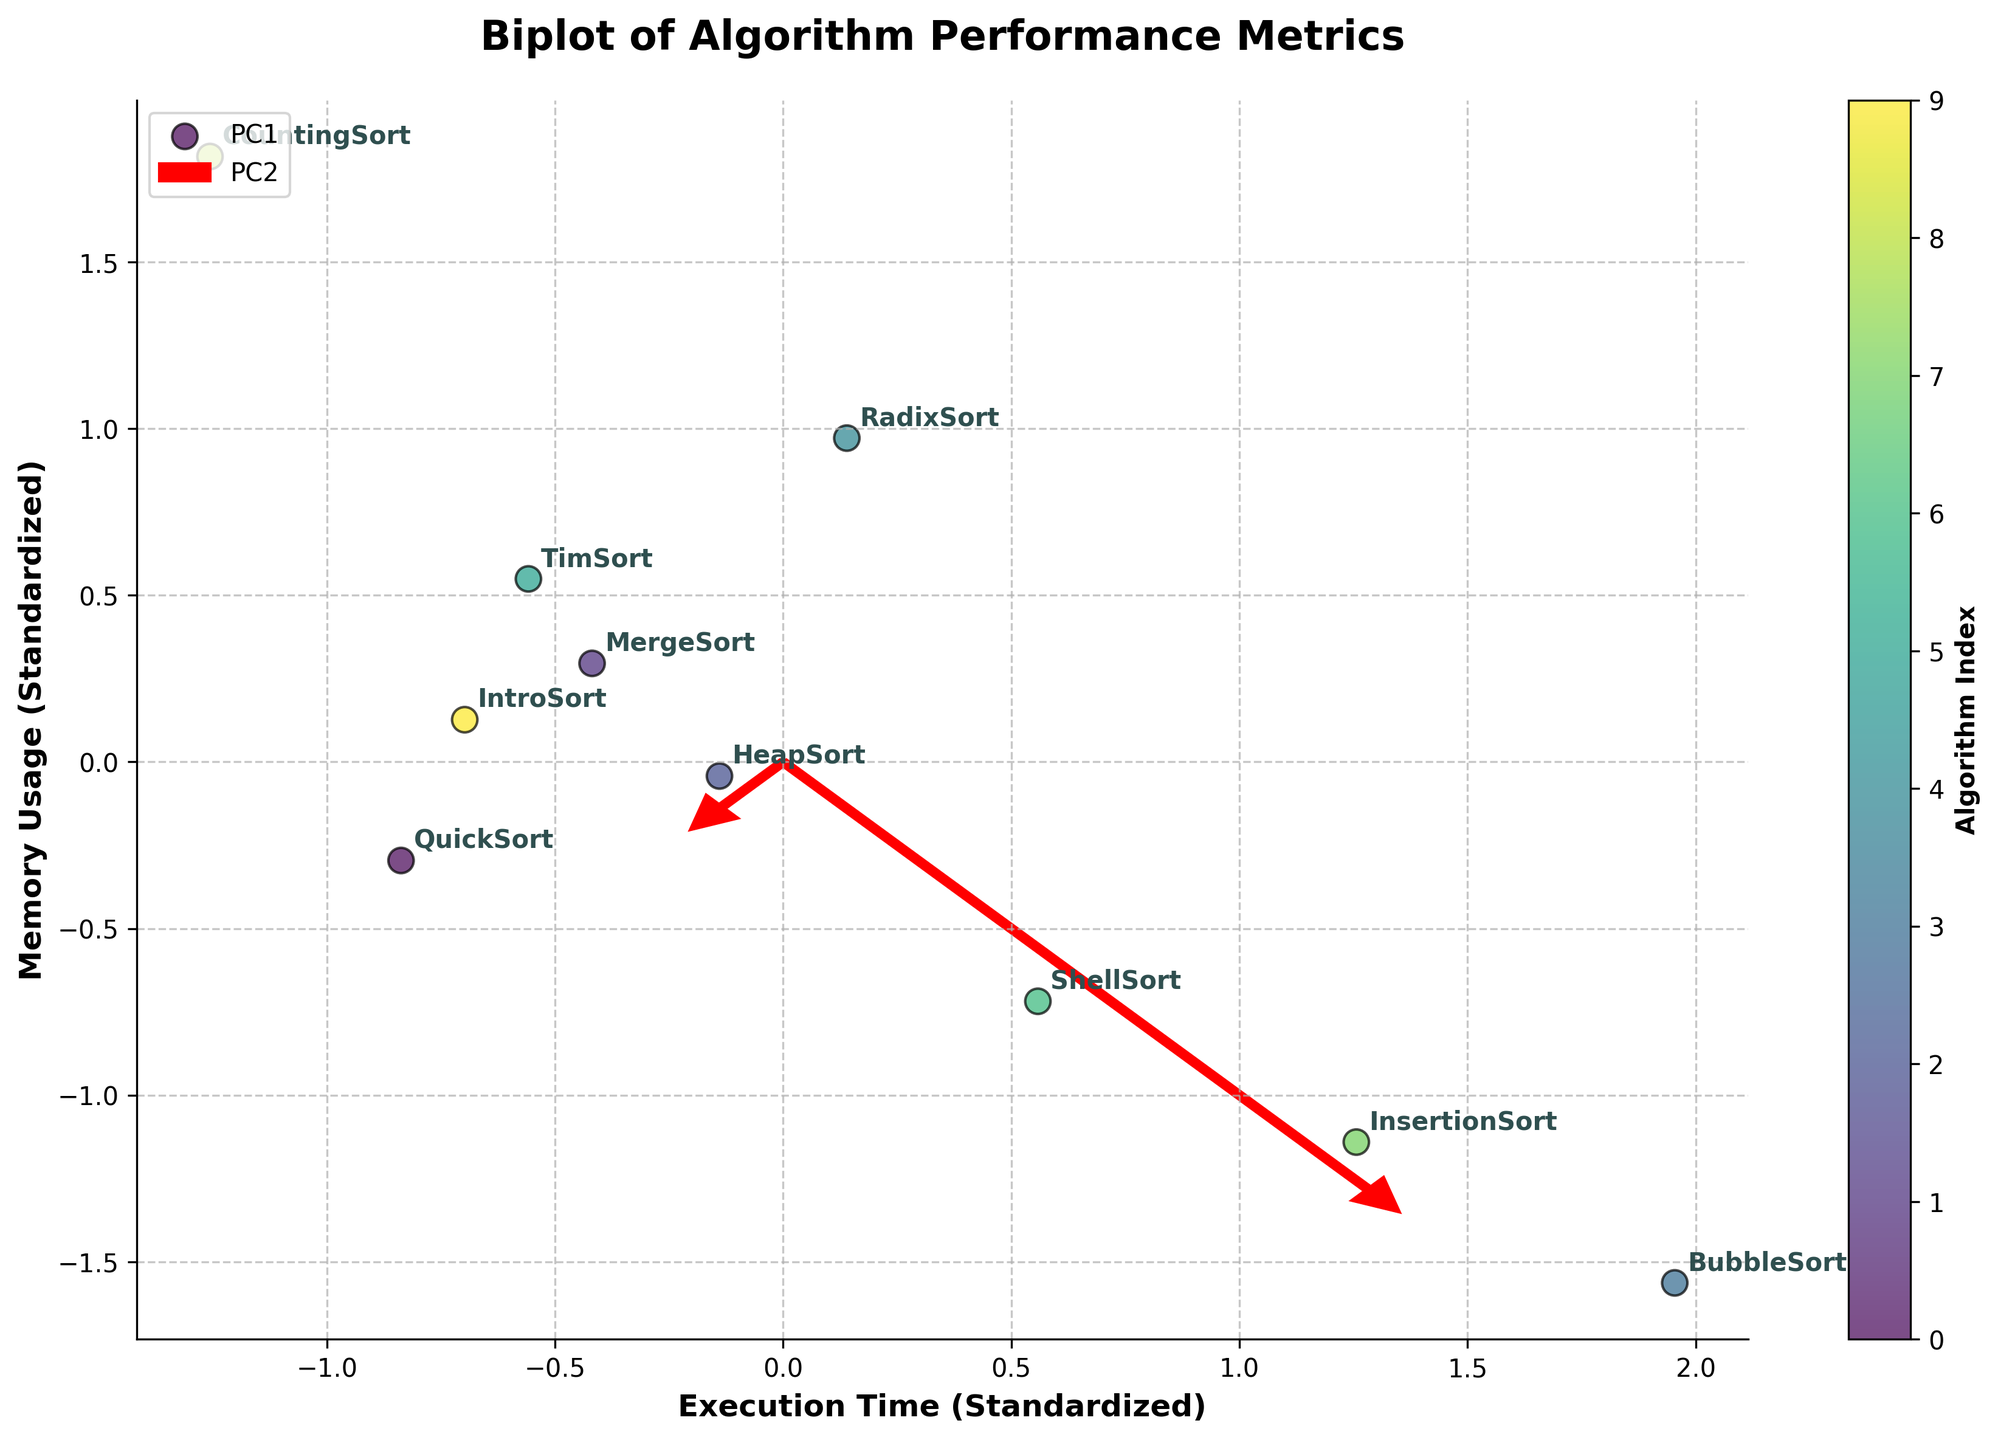What does the title of the plot indicate? The title of the plot, "Biplot of Algorithm Performance Metrics," indicates that it shows a biplot comparing different software algorithms based on their performance metrics, specifically execution time and memory usage.
Answer: Biplot of Algorithm Performance Metrics Which algorithm has the highest memory usage? CountingSort has the highest memory usage as it is placed furthest along the memory usage axis when standardized values are considered.
Answer: CountingSort How are the eigenvectors represented in the plot? The eigenvectors are represented as red arrows originating from the origin. They indicate the principal components (PC1 and PC2) and their directions in the standardized space.
Answer: Red arrows Which algorithms have execution times closest to the average? TimSort, QuickSort, and IntroSort have execution times that are closest to the average as their points are near the zero mark on the standardized execution time axis.
Answer: TimSort, QuickSort, IntroSort How many total data points (algorithms) are displayed in the plot? There are 10 data points, each representing a different algorithm, as indicated by the labels for each point on the plot.
Answer: 10 Which algorithm exhibits the lowest execution time? CountingSort exhibits the lowest execution time, as it is positioned furthest to the left along the execution time axis when standardized values are considered.
Answer: CountingSort What can you infer about the relationship between execution time and memory usage from the plot? The biplot indicates that there is no strong linear relationship between standardized execution time and memory usage, as the points are scattered without a clear pattern along the axes.
Answer: No strong relationship Do the majority of algorithms have execution times above or below the average? The majority of the algorithms have execution times around the average, as many points cluster around the zero mark on the standardized execution time axis.
Answer: Around the average Which algorithms use more memory than the average but also have above-average execution times? RadixSort and TimSort use more memory than the average and also have above-average execution times as they are positioned in the upper right quadrant of the standardized axes.
Answer: RadixSort, TimSort How many principal components are represented, and which is given more importance? Two principal components (PC1 and PC2) are represented, with PC1 given more importance as its eigenvector's arrow is longer, indicating that it explains more variance in the data.
Answer: Two, PC1 